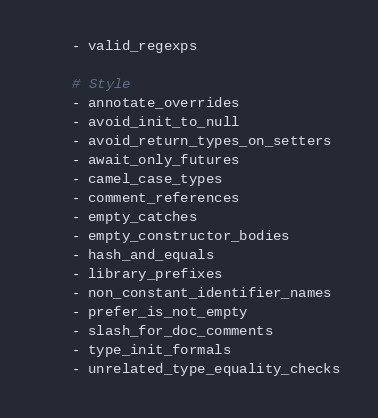<code> <loc_0><loc_0><loc_500><loc_500><_YAML_>    - valid_regexps

    # Style
    - annotate_overrides
    - avoid_init_to_null
    - avoid_return_types_on_setters
    - await_only_futures
    - camel_case_types
    - comment_references
    - empty_catches
    - empty_constructor_bodies
    - hash_and_equals
    - library_prefixes
    - non_constant_identifier_names
    - prefer_is_not_empty
    - slash_for_doc_comments
    - type_init_formals
    - unrelated_type_equality_checks</code> 